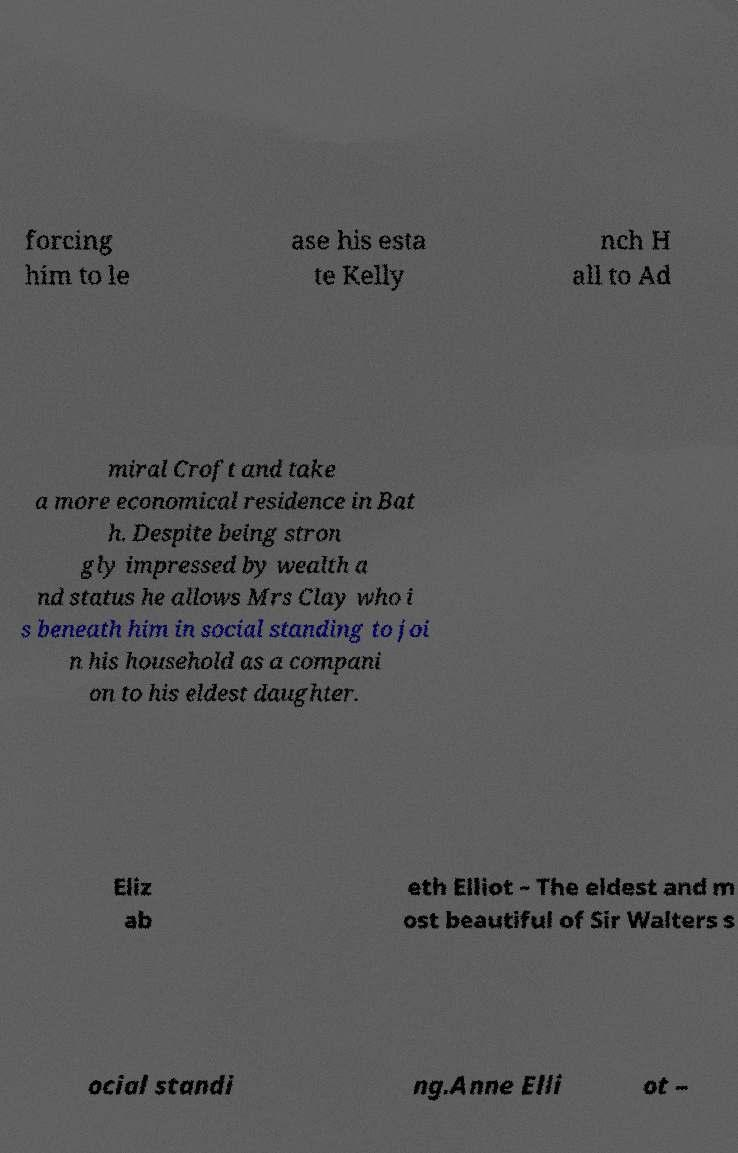Please identify and transcribe the text found in this image. forcing him to le ase his esta te Kelly nch H all to Ad miral Croft and take a more economical residence in Bat h. Despite being stron gly impressed by wealth a nd status he allows Mrs Clay who i s beneath him in social standing to joi n his household as a compani on to his eldest daughter. Eliz ab eth Elliot – The eldest and m ost beautiful of Sir Walters s ocial standi ng.Anne Elli ot – 